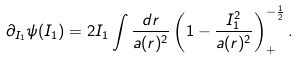<formula> <loc_0><loc_0><loc_500><loc_500>\partial _ { I _ { 1 } } \psi ( I _ { 1 } ) = 2 I _ { 1 } \int \frac { d r } { a ( r ) ^ { 2 } } \left ( 1 - \frac { I _ { 1 } ^ { 2 } } { a ( r ) ^ { 2 } } \right ) _ { + } ^ { - \frac { 1 } { 2 } } .</formula> 